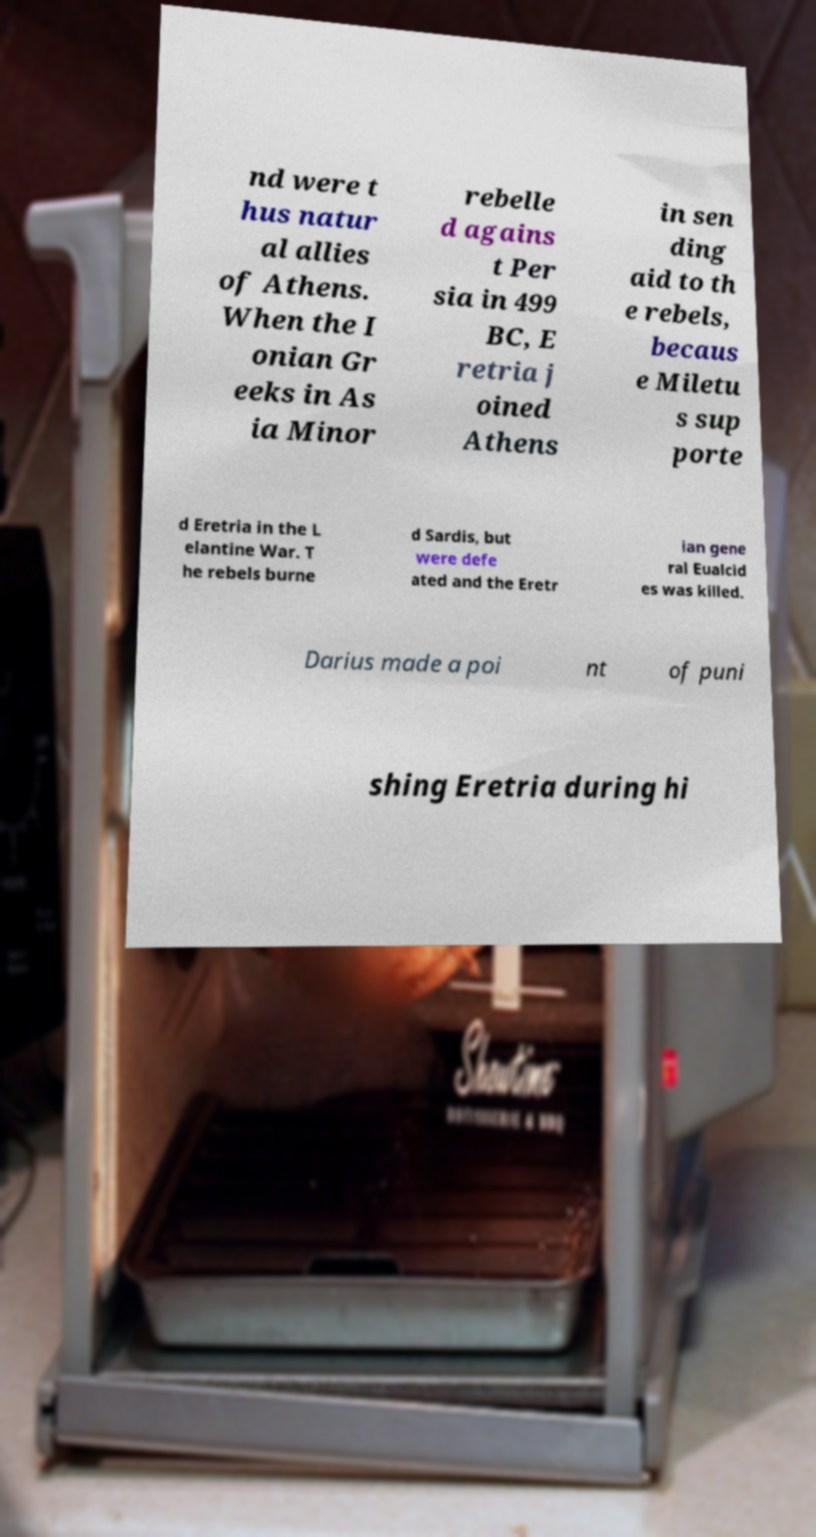For documentation purposes, I need the text within this image transcribed. Could you provide that? nd were t hus natur al allies of Athens. When the I onian Gr eeks in As ia Minor rebelle d agains t Per sia in 499 BC, E retria j oined Athens in sen ding aid to th e rebels, becaus e Miletu s sup porte d Eretria in the L elantine War. T he rebels burne d Sardis, but were defe ated and the Eretr ian gene ral Eualcid es was killed. Darius made a poi nt of puni shing Eretria during hi 